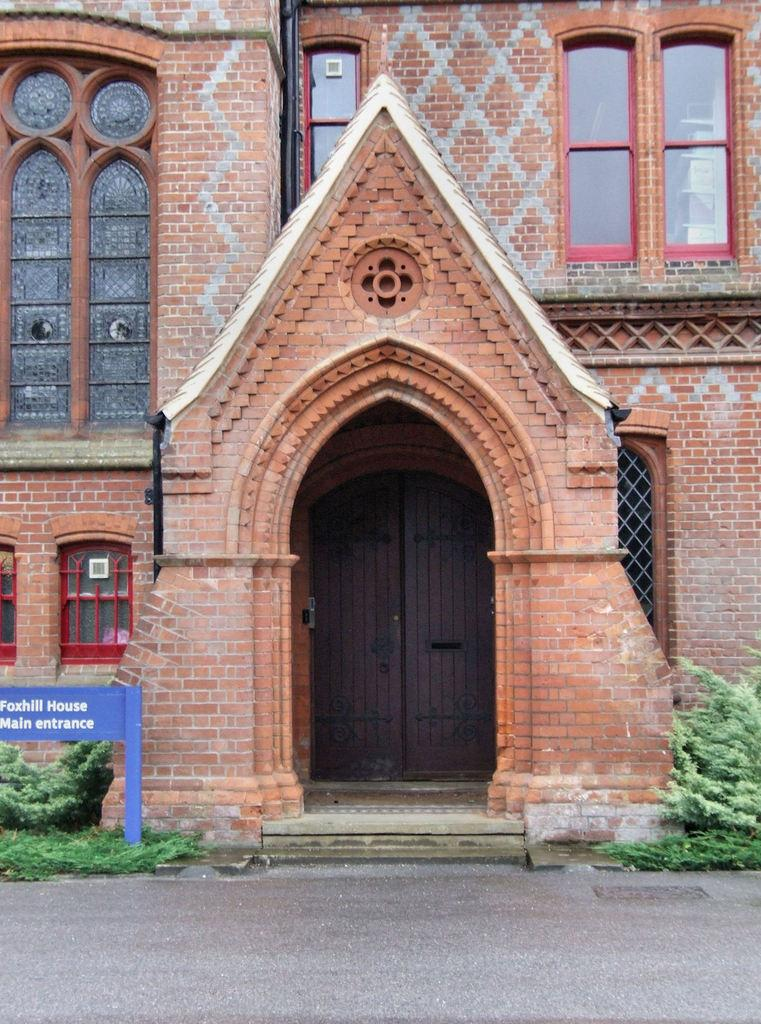What type of structure is present in the image? There is a building in the image. What features can be seen on the building? The building has doors and windows. What else is visible in the image besides the building? There are plants in the image. What is located on the left side of the image? There is a board with text on the left side of the image. How many fingers can be seen on the building in the image? There are no fingers visible on the building in the image. Is there any evidence of a crime taking place in the image? There is no indication of a crime in the image; it simply shows a building with doors, windows, plants, and a board with text. 